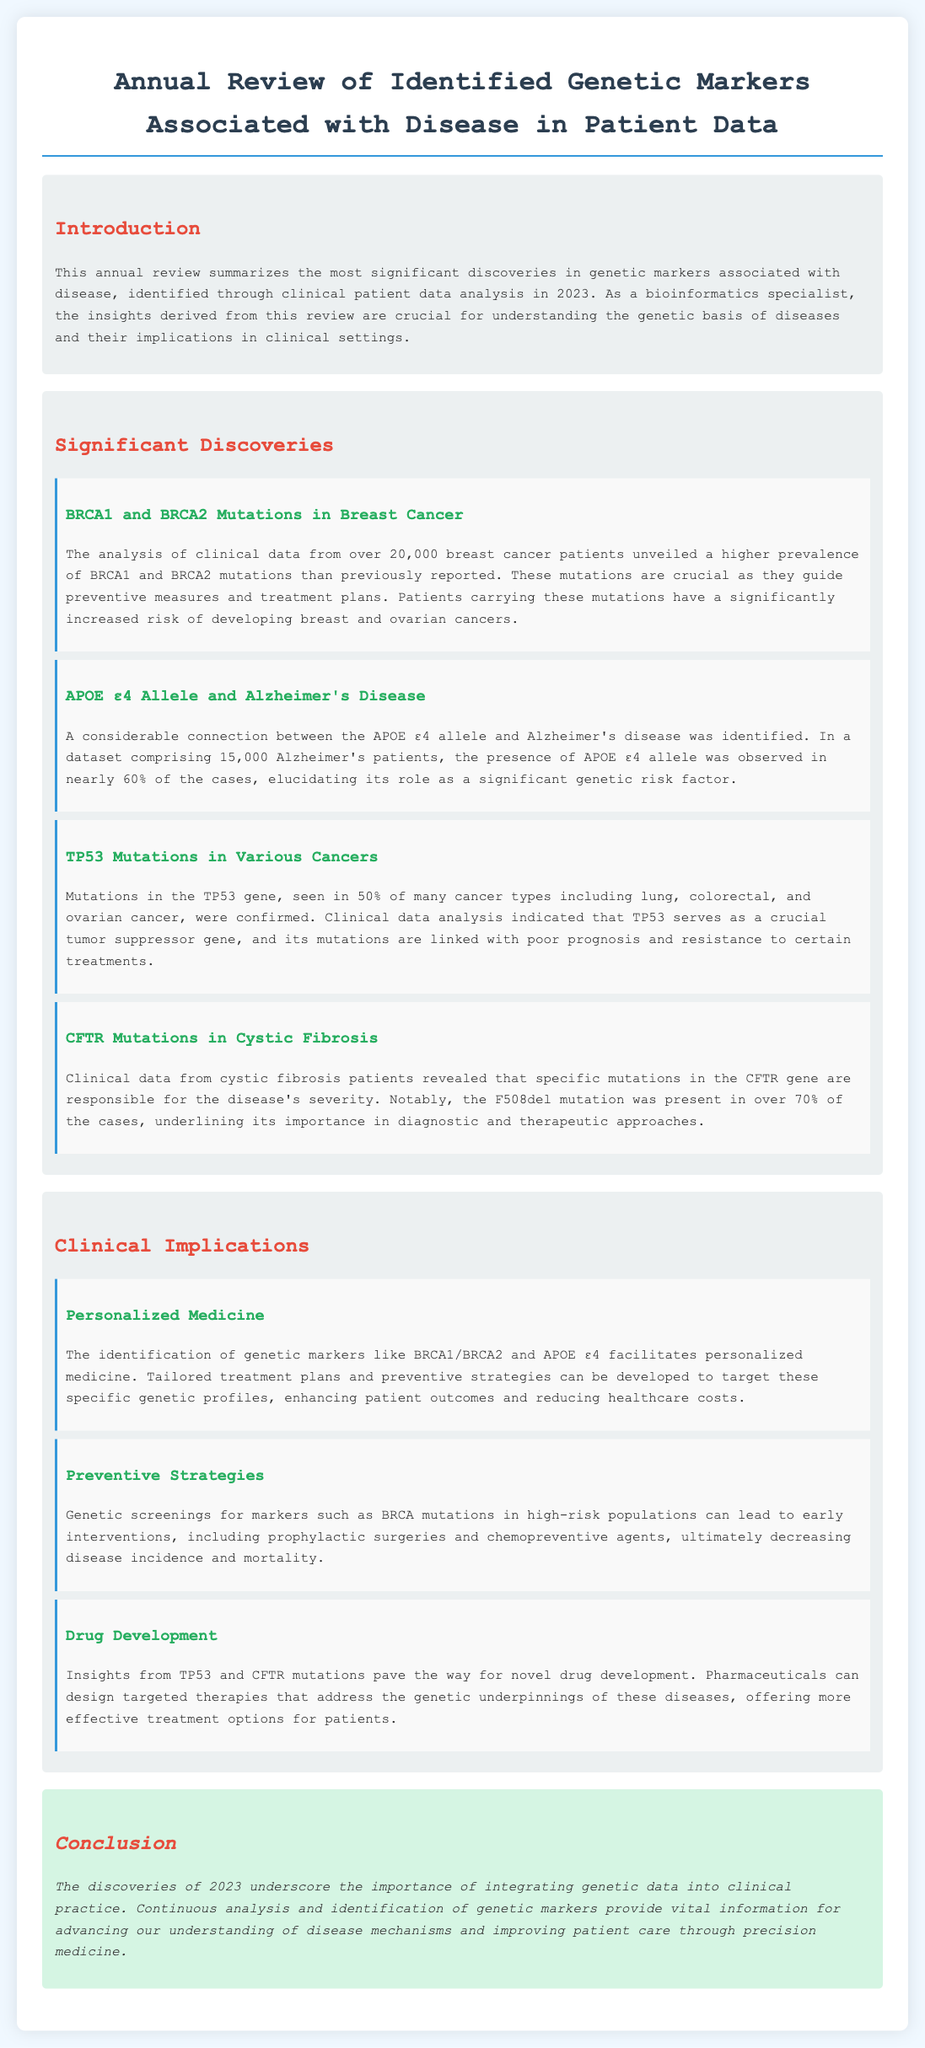What gene mutations are often associated with breast cancer? The document mentions that the BRCA1 and BRCA2 mutations are often associated with breast cancer, based on the analysis of clinical data from patients.
Answer: BRCA1 and BRCA2 What is the percentage of Alzheimer's patients that have the APOE ε4 allele? According to the review, nearly 60% of the Alzheimer's patients in the dataset were found to have the APOE ε4 allele.
Answer: 60% In how many cancer types are TP53 mutations confirmed? The document states that TP53 mutations are seen in 50% of several cancer types including lung, colorectal, and ovarian cancer, highlighting the significance of this mutation.
Answer: Several What is the main CFTR mutation responsible for severity in cystic fibrosis? The review identifies the F508del mutation as being present in over 70% of cystic fibrosis cases.
Answer: F508del How do BRCA1/BRCA2 mutations contribute to clinical approaches? It explains that the identification of BRCA1 and BRCA2 facilitates personalized medicine, allowing for tailored treatment plans and preventive strategies.
Answer: Personalized medicine What is the role of TP53 according to the document? The document highlights TP53 as a crucial tumor suppressor gene linked with poor prognosis and treatment resistance in various cancers.
Answer: Tumor suppressor gene What type of drug development is supported by insights from TP53 and CFTR mutations? The review suggests that insights from these mutations pave the way for novel drug development targeted at the genetic underpinnings of diseases.
Answer: Novel drug development What therapeutic approach can result from identifying genetic markers in high-risk populations? It mentions that genetic screenings for markers such as BRCA mutations can lead to early interventions like prophylactic surgeries.
Answer: Early interventions 